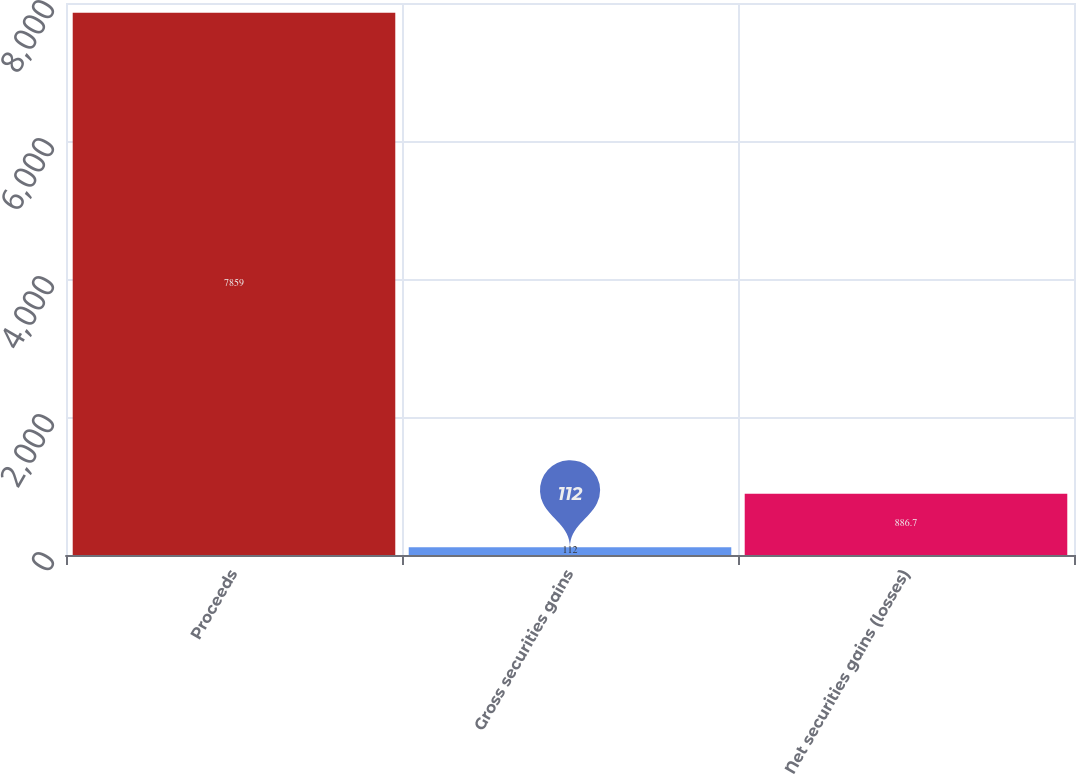<chart> <loc_0><loc_0><loc_500><loc_500><bar_chart><fcel>Proceeds<fcel>Gross securities gains<fcel>Net securities gains (losses)<nl><fcel>7859<fcel>112<fcel>886.7<nl></chart> 